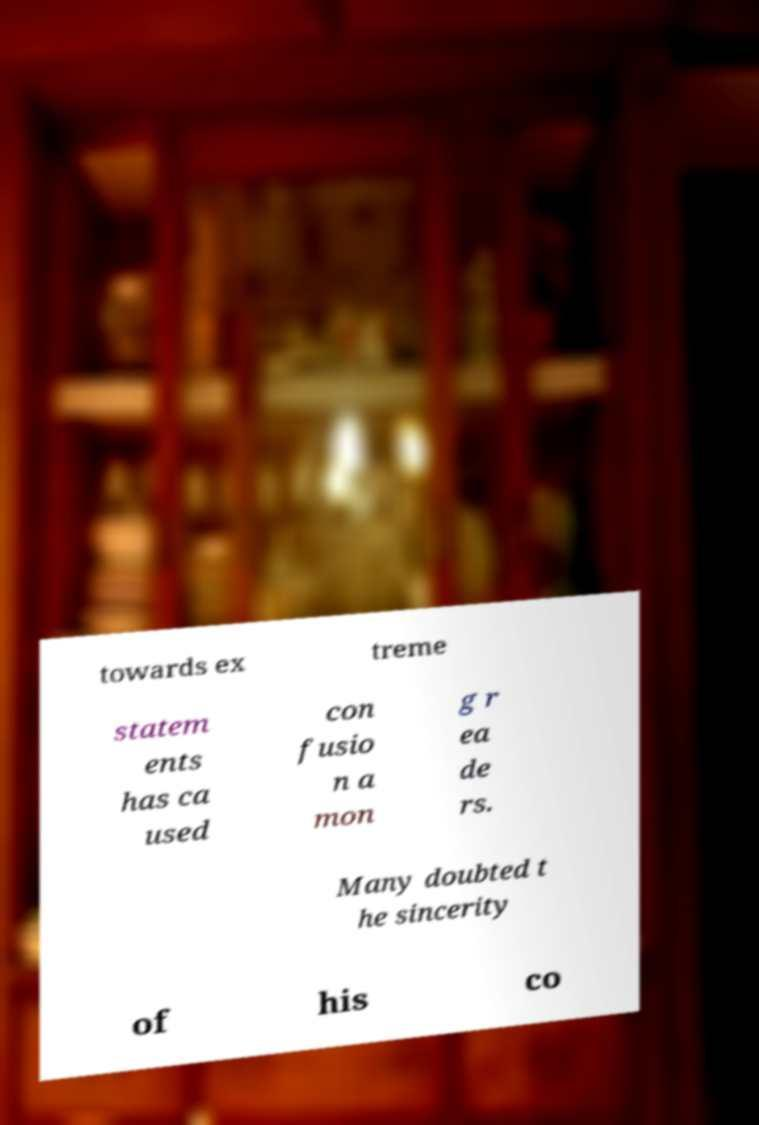Can you read and provide the text displayed in the image?This photo seems to have some interesting text. Can you extract and type it out for me? towards ex treme statem ents has ca used con fusio n a mon g r ea de rs. Many doubted t he sincerity of his co 